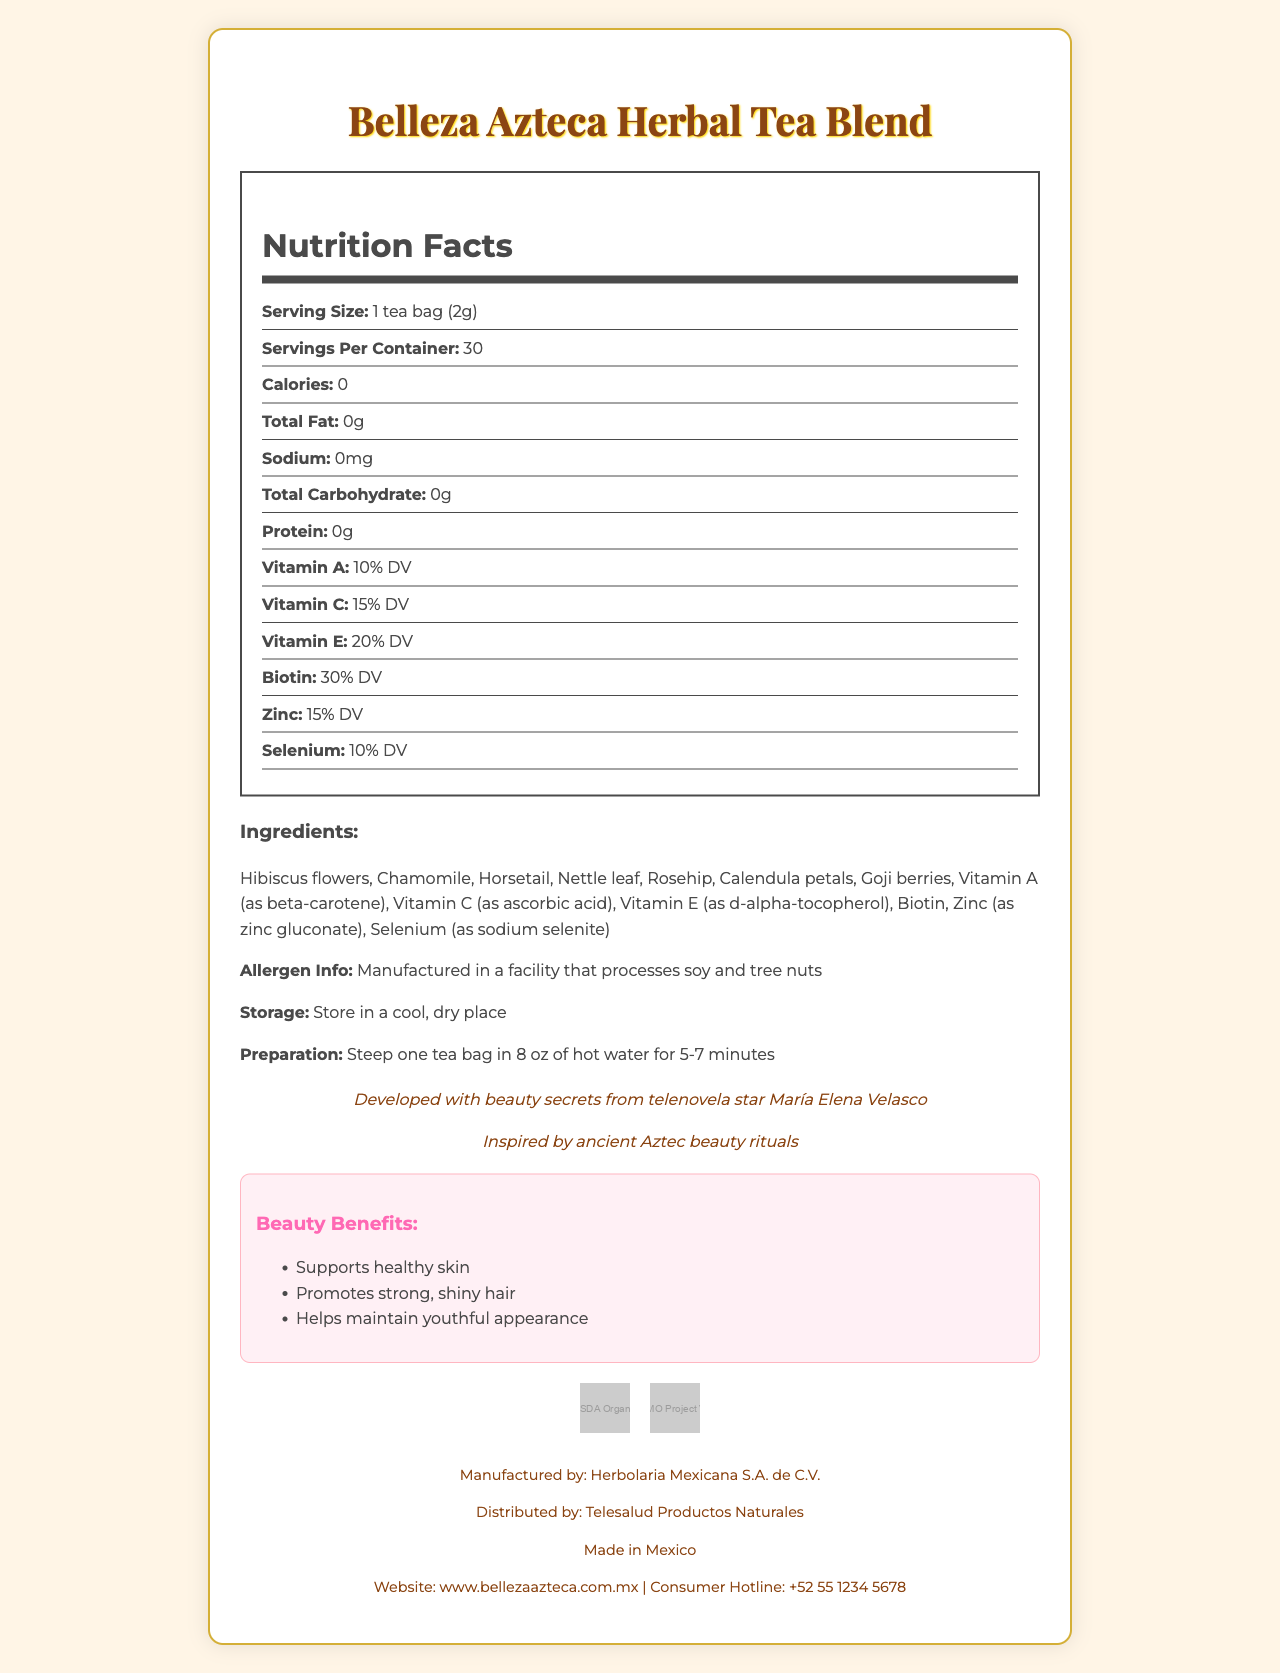what is the serving size of Belleza Azteca Herbal Tea Blend? The document specifies the serving size directly under the Nutrition Facts, stating "Serving Size: 1 tea bag (2g)".
Answer: 1 tea bag (2g) how many servings are there per container? The document states this information under the Nutrition Facts, indicating "Servings Per Container: 30".
Answer: 30 how many calories does each serving contain? This is mentioned directly in the Nutrition Facts as "Calories: 0".
Answer: 0 List the vitamins provided in this tea and their Daily Value percentages. The document provides this information under the Nutrition Facts with each vitamin and its daily value percentage listed.
Answer: Vitamin A - 10% DV, Vitamin C - 15% DV, Vitamin E - 20% DV, Biotin - 30% DV, Zinc - 15% DV, Selenium - 10% DV which ingredient in Belleza Azteca Herbal Tea Blend is used for beta-carotene source? The document lists Vitamin A as beta-carotene in the ingredients section.
Answer: Vitamin A Does Belleza Azteca Herbal Tea Blend contain any calories, fats, sodium, carbohydrates, or proteins? According to the Nutrition Facts, all these values are listed as 0.
Answer: No What facility-related allergen information is provided for this product? This is mentioned under the Allergen Info section of the document.
Answer: Manufactured in a facility that processes soy and tree nuts What is the primary traditional inspiration behind the Belleza Azteca Herbal Tea Blend? This is mentioned under the traditional claims section of the document.
Answer: Inspired by ancient Aztec beauty rituals where should Belleza Azteca Herbal Tea Blend be stored? The storage instructions section provides this information.
Answer: Store in a cool, dry place who developed this herbal tea blend? It is stated in the document that the tea blend was developed with beauty secrets from telenovela star María Elena Velasco.
Answer: María Elena Velasco What are the beauty benefits associated with Belleza Azteca Herbal Tea Blend? The document lists these benefits under the Beauty Benefits section.
Answer: Supports healthy skin, Promotes strong, shiny hair, Helps maintain youthful appearance How should the Belleza Azteca Herbal Tea Blend be prepared? A. Boil for 10 minutes B. Steep one tea bag in 8 oz of hot water for 5-7 minutes C. Mix with cold water The document provides preparation instructions stating, "Steep one tea bag in 8 oz of hot water for 5-7 minutes".
Answer: B how many grams of total fat are in each serving? A. 0g B. 1g C. 2g D. 5g The Nutrition Facts in the document list the total fat per serving as 0g.
Answer: A Is this product non-GMO verified? The document includes a certification for "Non-GMO Project Verified".
Answer: Yes Summarize the main idea of the Belleza Azteca Herbal Tea Blend document. The summary captures the main points from the document, such as the product's health benefits, nutritional content, traditional inspiration, endorsements, and certifications.
Answer: Belleza Azteca Herbal Tea Blend is an herbal tea designed to support skin and hair health with vitamins and minerals. It contains zero calories, fats, sodium, carbohydrates, or proteins, and includes ingredients like hibiscus flowers, chamomile, and various vitamins. It is inspired by ancient Aztec beauty rituals and endorsed by telenovela star María Elena Velasco, with multiple beauty benefits and USDA Organic and Non-GMO certifications. What is the exact amount of Vitamin B12 included in the Belleza Azteca Herbal Tea Blend? The document does not provide any information on Vitamin B12 content.
Answer: Not enough information 